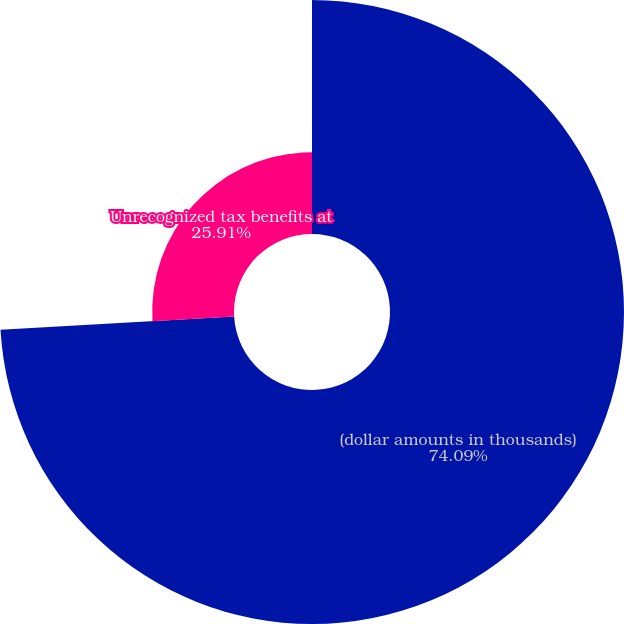Convert chart. <chart><loc_0><loc_0><loc_500><loc_500><pie_chart><fcel>(dollar amounts in thousands)<fcel>Unrecognized tax benefits at<nl><fcel>74.09%<fcel>25.91%<nl></chart> 